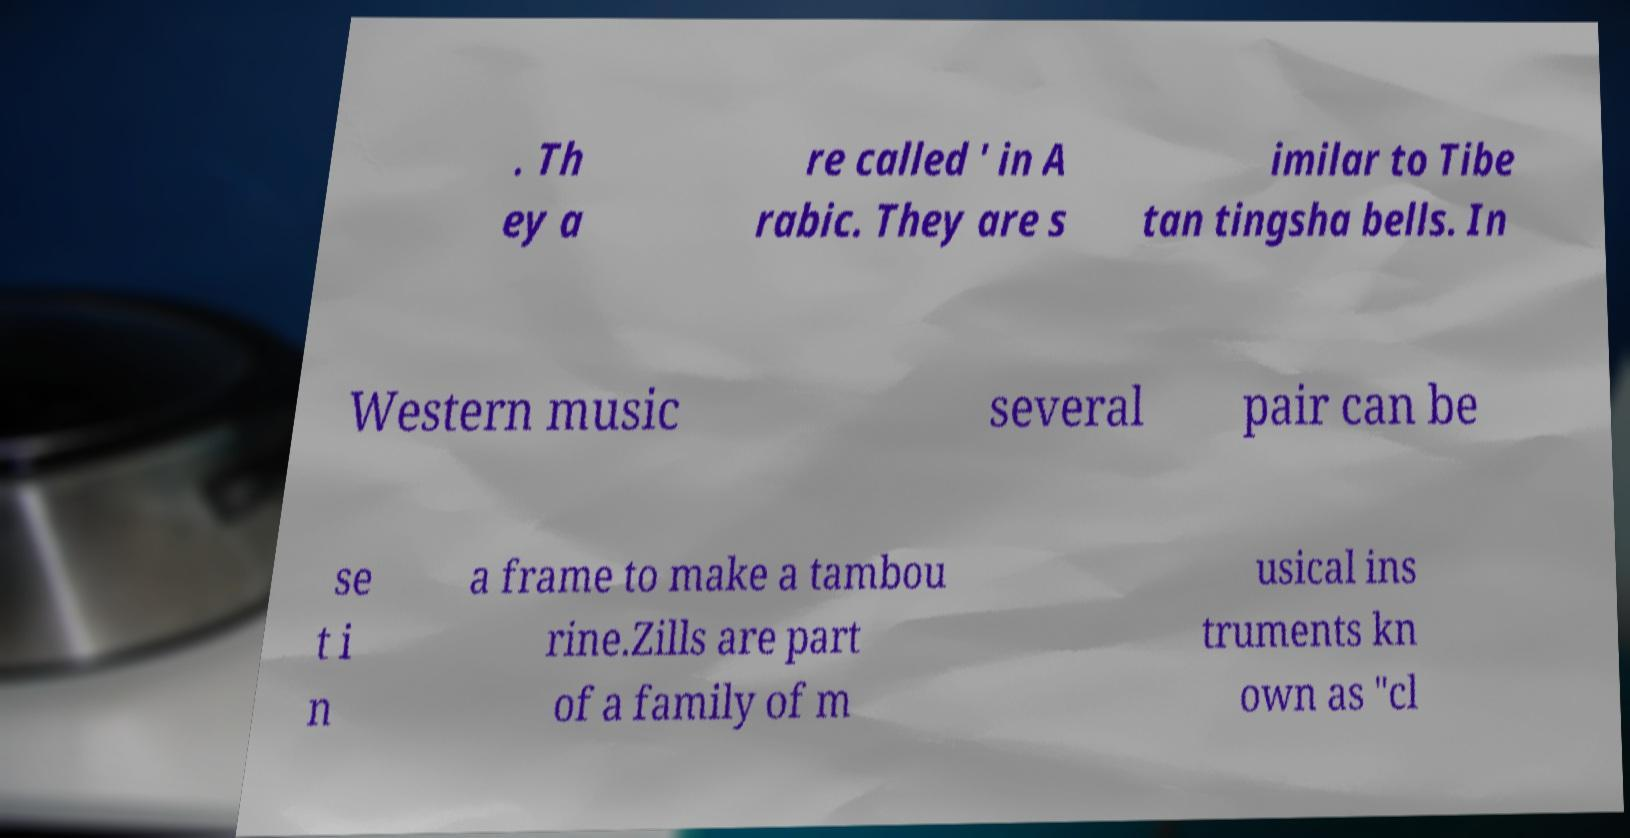Can you accurately transcribe the text from the provided image for me? . Th ey a re called ' in A rabic. They are s imilar to Tibe tan tingsha bells. In Western music several pair can be se t i n a frame to make a tambou rine.Zills are part of a family of m usical ins truments kn own as "cl 